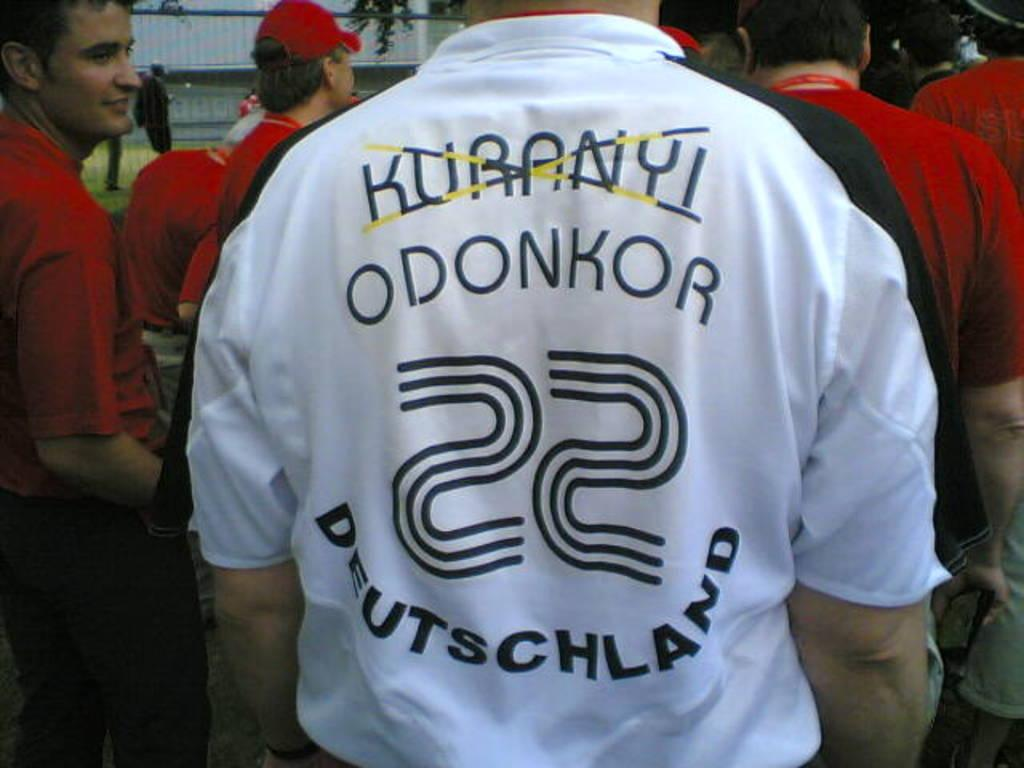<image>
Create a compact narrative representing the image presented. A man is wearing a white shirt with Deutschland written across the back. 